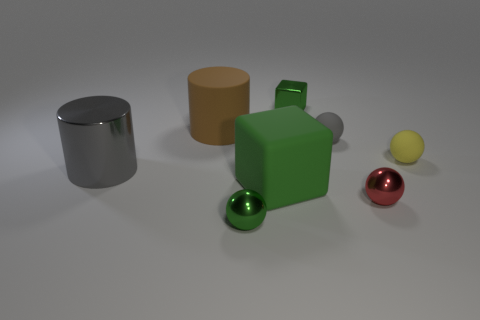Can you describe the lighting in the scene? The scene is softly lit from above, as indicated by the gentle shadows beneath the objects. The diffuse quality of the light suggests an overcast sky or a softbox light source, which reduces harsh shadows and provides a uniform illumination to highlight the forms and textures of the objects. 